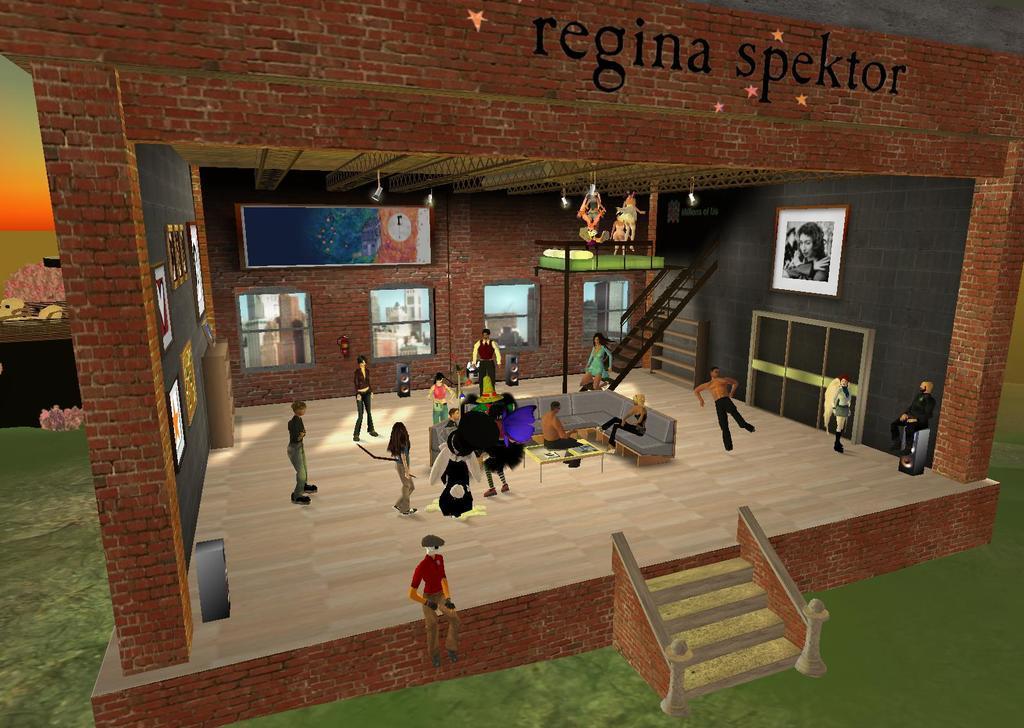In one or two sentences, can you explain what this image depicts? This is an animated image we can see a group of persons in the middle of this image and there is a wall in the background. There is a photo frame attached to the wall as we can see on the right side of this image. There is some text written at the top of this image. 